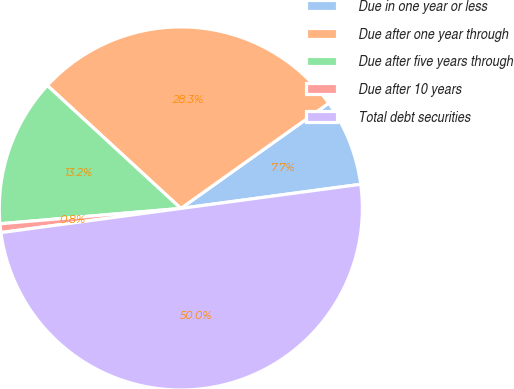Convert chart. <chart><loc_0><loc_0><loc_500><loc_500><pie_chart><fcel>Due in one year or less<fcel>Due after one year through<fcel>Due after five years through<fcel>Due after 10 years<fcel>Total debt securities<nl><fcel>7.72%<fcel>28.31%<fcel>13.19%<fcel>0.78%<fcel>50.0%<nl></chart> 